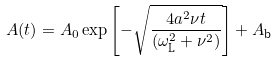<formula> <loc_0><loc_0><loc_500><loc_500>A ( t ) = A _ { 0 } \exp \left [ - \sqrt { \frac { 4 a ^ { 2 } \nu t } { ( \omega _ { \text {L} } ^ { 2 } + \nu ^ { 2 } ) } } \right ] + A _ { \text {b} }</formula> 